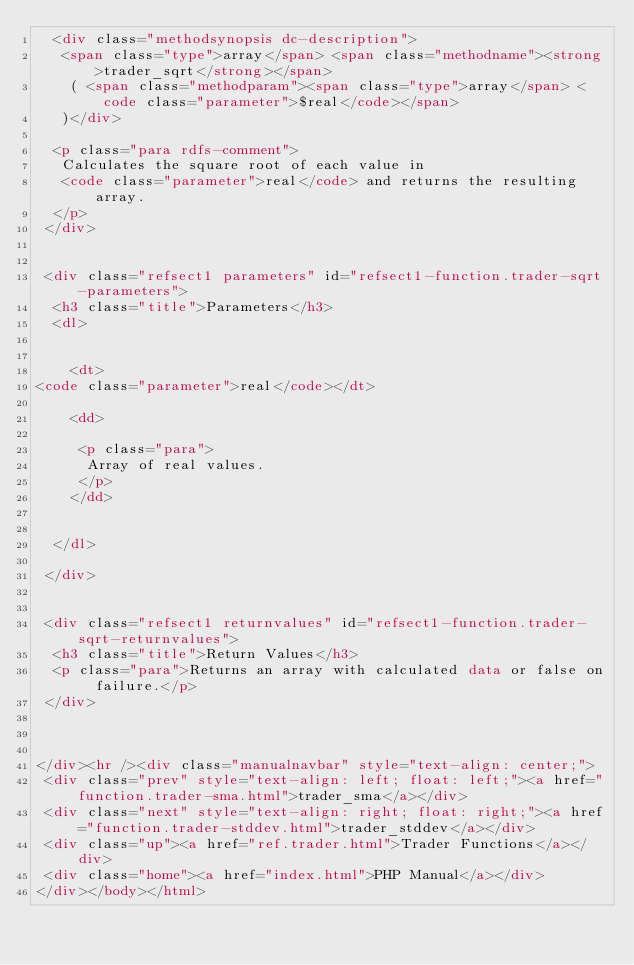Convert code to text. <code><loc_0><loc_0><loc_500><loc_500><_HTML_>  <div class="methodsynopsis dc-description">
   <span class="type">array</span> <span class="methodname"><strong>trader_sqrt</strong></span>
    ( <span class="methodparam"><span class="type">array</span> <code class="parameter">$real</code></span>
   )</div>

  <p class="para rdfs-comment">
   Calculates the square root of each value in
   <code class="parameter">real</code> and returns the resulting array.
  </p>
 </div>


 <div class="refsect1 parameters" id="refsect1-function.trader-sqrt-parameters">
  <h3 class="title">Parameters</h3>
  <dl>

   
    <dt>
<code class="parameter">real</code></dt>

    <dd>

     <p class="para">
      Array of real values.      
     </p>
    </dd>

   
  </dl>

 </div>


 <div class="refsect1 returnvalues" id="refsect1-function.trader-sqrt-returnvalues">
  <h3 class="title">Return Values</h3>
  <p class="para">Returns an array with calculated data or false on failure.</p>
 </div>



</div><hr /><div class="manualnavbar" style="text-align: center;">
 <div class="prev" style="text-align: left; float: left;"><a href="function.trader-sma.html">trader_sma</a></div>
 <div class="next" style="text-align: right; float: right;"><a href="function.trader-stddev.html">trader_stddev</a></div>
 <div class="up"><a href="ref.trader.html">Trader Functions</a></div>
 <div class="home"><a href="index.html">PHP Manual</a></div>
</div></body></html>
</code> 